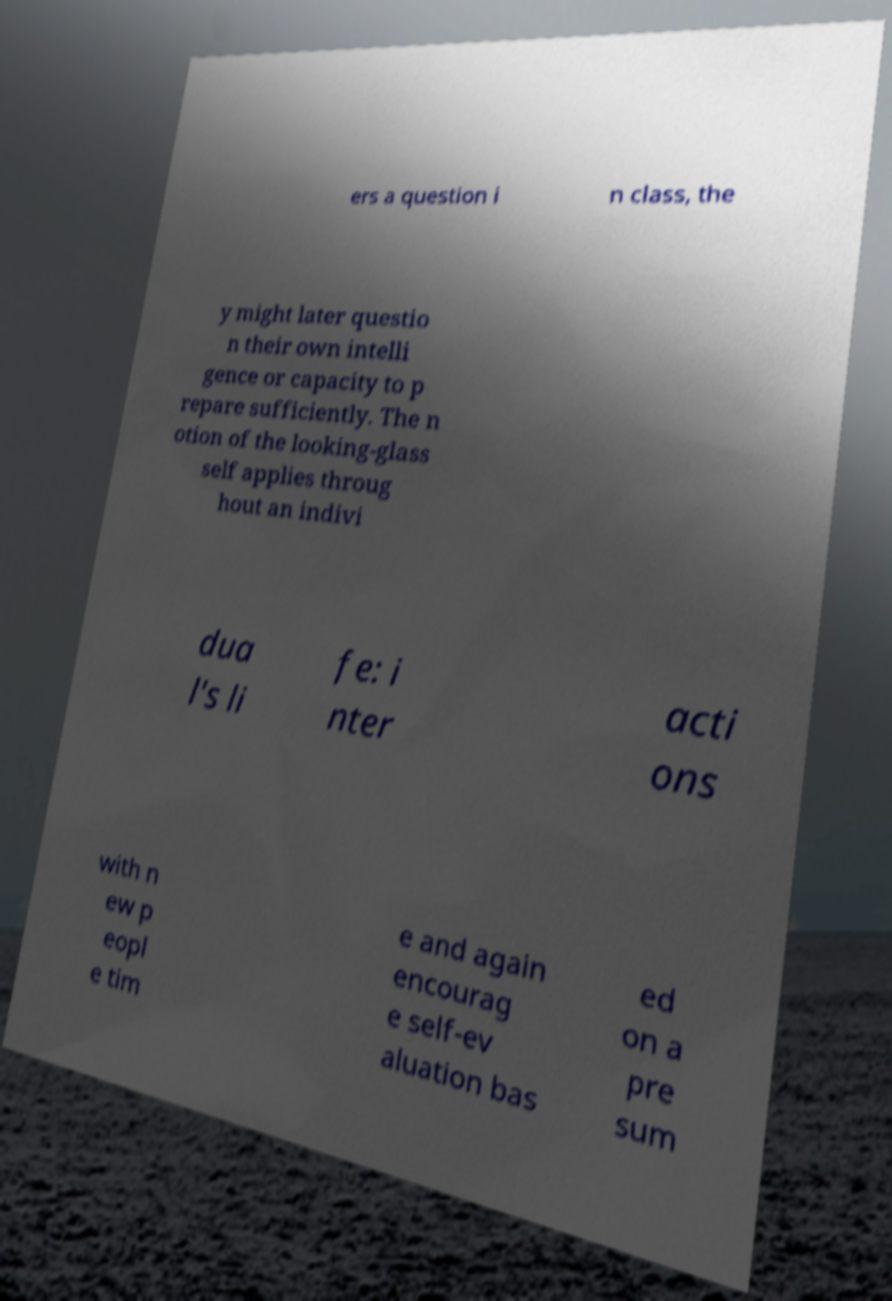Can you read and provide the text displayed in the image?This photo seems to have some interesting text. Can you extract and type it out for me? ers a question i n class, the y might later questio n their own intelli gence or capacity to p repare sufficiently. The n otion of the looking-glass self applies throug hout an indivi dua l's li fe: i nter acti ons with n ew p eopl e tim e and again encourag e self-ev aluation bas ed on a pre sum 